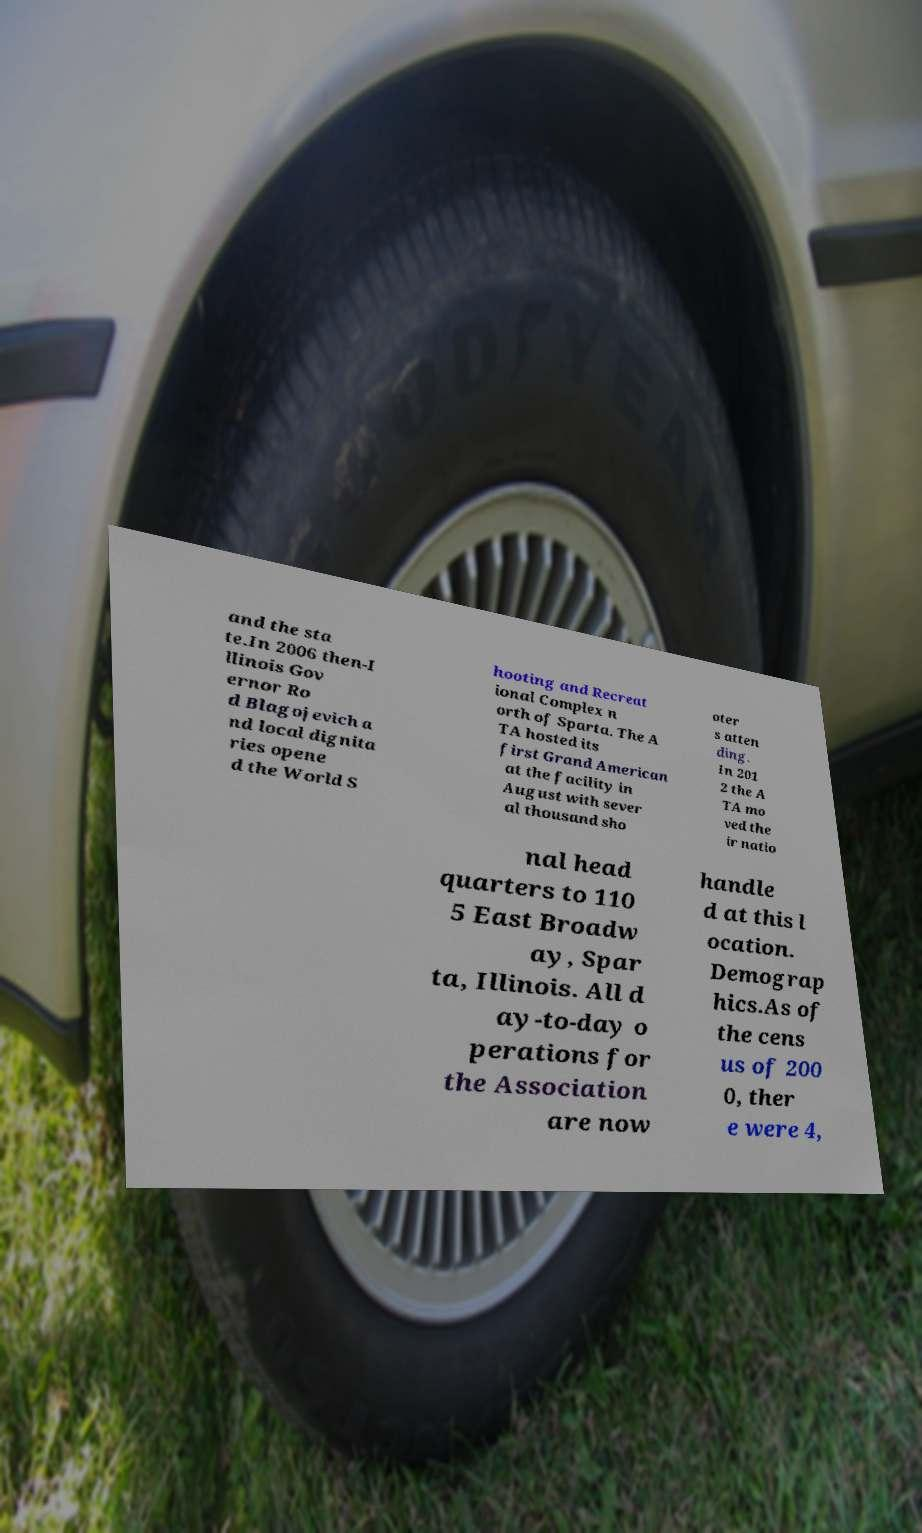Please read and relay the text visible in this image. What does it say? and the sta te.In 2006 then-I llinois Gov ernor Ro d Blagojevich a nd local dignita ries opene d the World S hooting and Recreat ional Complex n orth of Sparta. The A TA hosted its first Grand American at the facility in August with sever al thousand sho oter s atten ding. In 201 2 the A TA mo ved the ir natio nal head quarters to 110 5 East Broadw ay, Spar ta, Illinois. All d ay-to-day o perations for the Association are now handle d at this l ocation. Demograp hics.As of the cens us of 200 0, ther e were 4, 